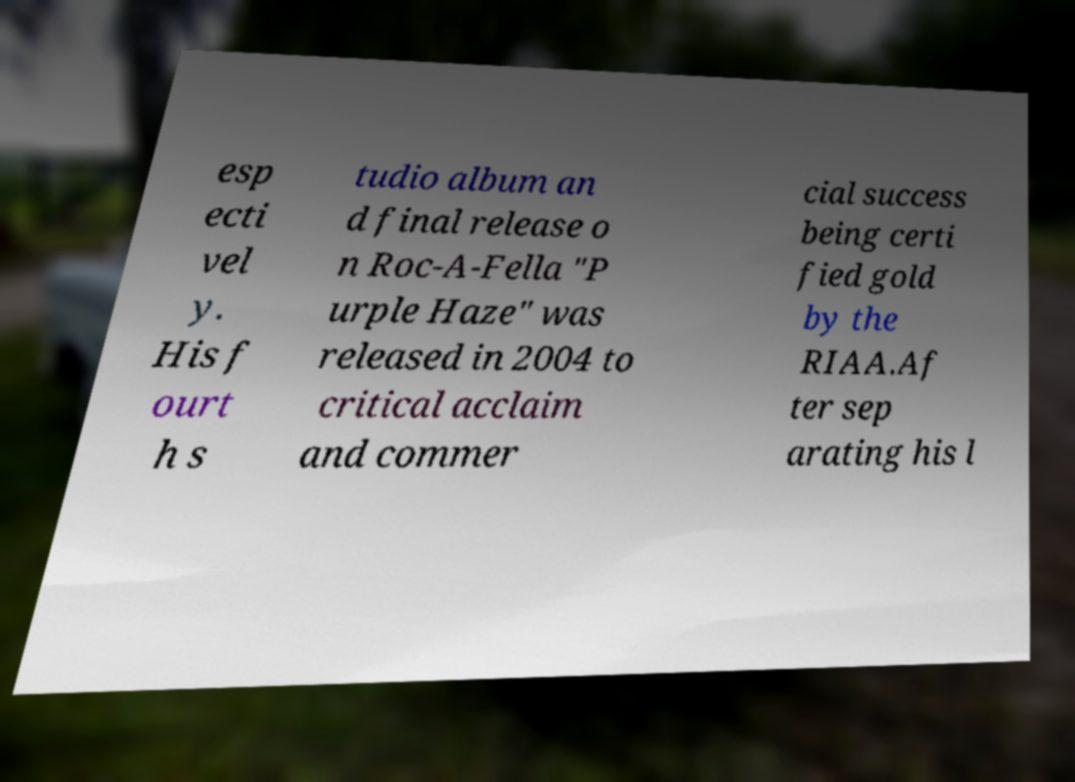Please identify and transcribe the text found in this image. esp ecti vel y. His f ourt h s tudio album an d final release o n Roc-A-Fella "P urple Haze" was released in 2004 to critical acclaim and commer cial success being certi fied gold by the RIAA.Af ter sep arating his l 